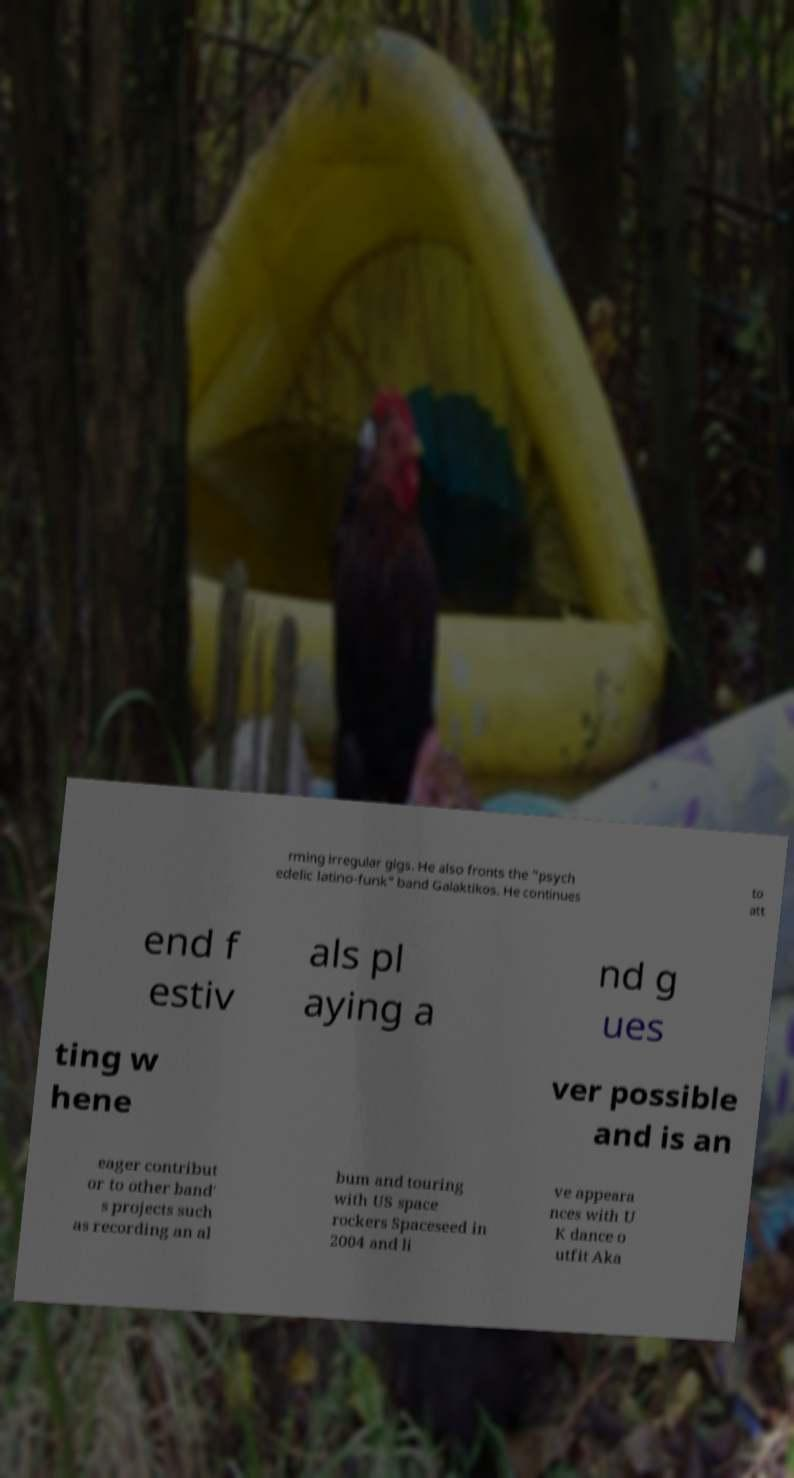Can you read and provide the text displayed in the image?This photo seems to have some interesting text. Can you extract and type it out for me? rming irregular gigs. He also fronts the "psych edelic latino-funk" band Galaktikos. He continues to att end f estiv als pl aying a nd g ues ting w hene ver possible and is an eager contribut or to other band' s projects such as recording an al bum and touring with US space rockers Spaceseed in 2004 and li ve appeara nces with U K dance o utfit Aka 